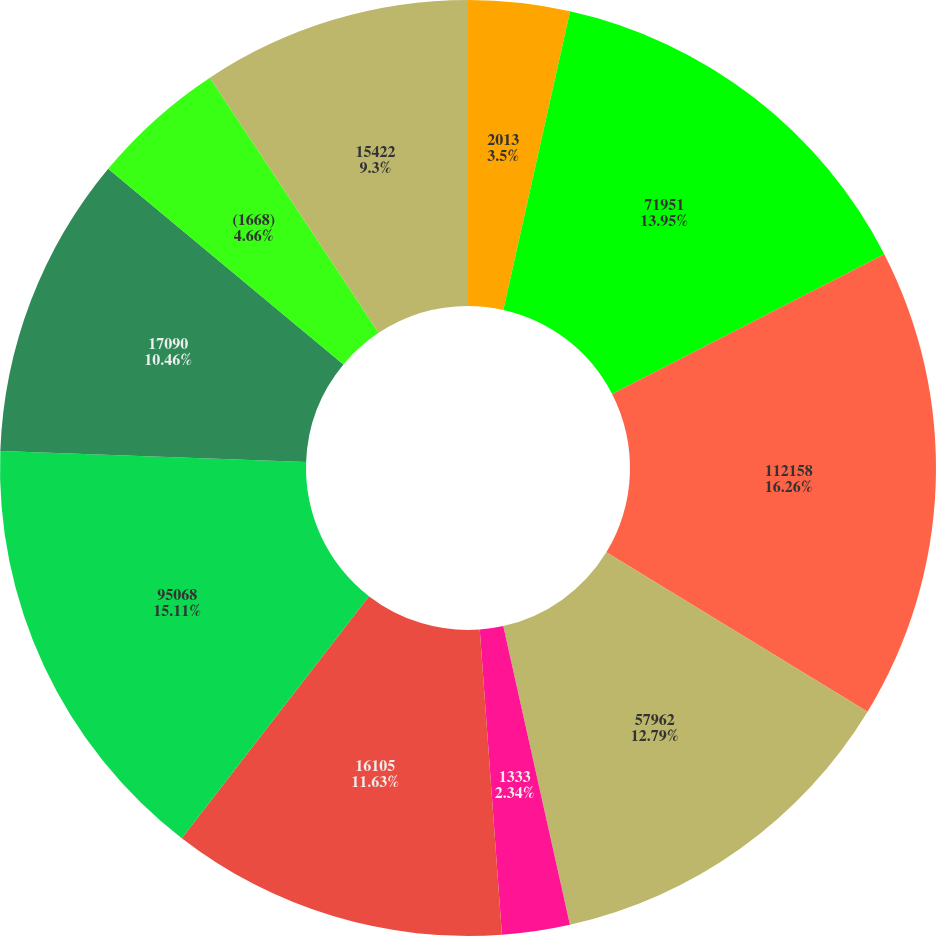Convert chart. <chart><loc_0><loc_0><loc_500><loc_500><pie_chart><fcel>2013<fcel>71951<fcel>112158<fcel>57962<fcel>1333<fcel>16105<fcel>95068<fcel>17090<fcel>(1668)<fcel>15422<nl><fcel>3.5%<fcel>13.95%<fcel>16.27%<fcel>12.79%<fcel>2.34%<fcel>11.63%<fcel>15.11%<fcel>10.46%<fcel>4.66%<fcel>9.3%<nl></chart> 